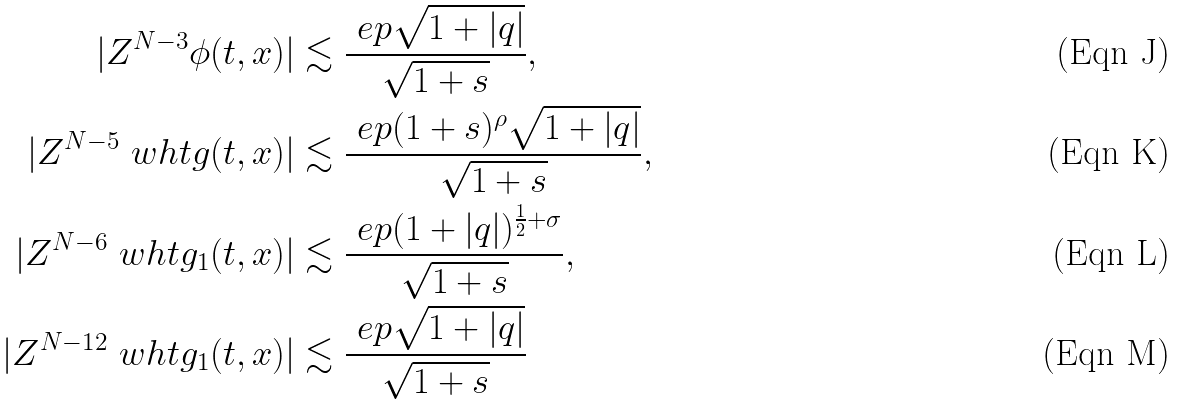Convert formula to latex. <formula><loc_0><loc_0><loc_500><loc_500>| Z ^ { N - 3 } \phi ( t , x ) | & \lesssim \frac { \ e p \sqrt { 1 + | q | } } { \sqrt { 1 + s } } , \\ | Z ^ { N - 5 } \ w h t g ( t , x ) | & \lesssim \frac { \ e p ( 1 + s ) ^ { \rho } \sqrt { 1 + | q | } } { \sqrt { 1 + s } } , \\ | Z ^ { N - 6 } \ w h t { g _ { 1 } } ( t , x ) | & \lesssim \frac { \ e p ( 1 + | q | ) ^ { \frac { 1 } { 2 } + \sigma } } { \sqrt { 1 + s } } , \\ | Z ^ { N - 1 2 } \ w h t { g _ { 1 } } ( t , x ) | & \lesssim \frac { \ e p \sqrt { 1 + | q | } } { \sqrt { 1 + s } }</formula> 